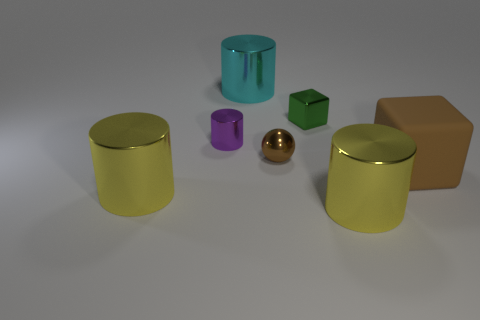Can you describe the shapes and colors of the objects in the image? Certainly! There are six objects with varying shapes and colors. Starting from the left, there is a yellow cylindrical can, a teal cylindrical can with a more reflective surface, a small purple cylinder, a reflective golden sphere, a green cube, and a brown rectangular box. 